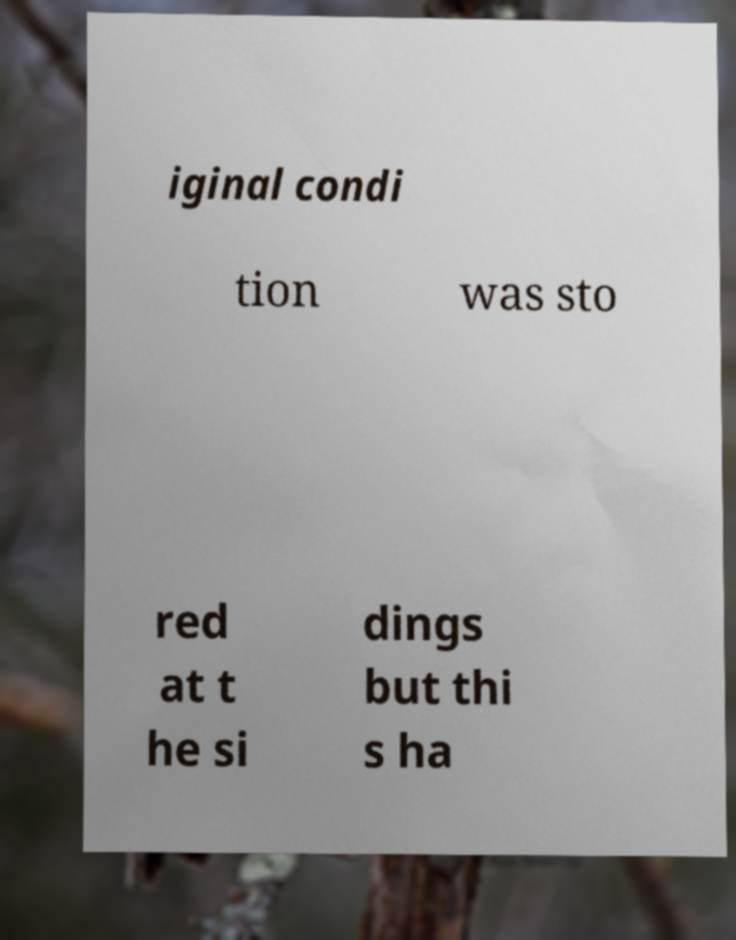Can you read and provide the text displayed in the image?This photo seems to have some interesting text. Can you extract and type it out for me? iginal condi tion was sto red at t he si dings but thi s ha 